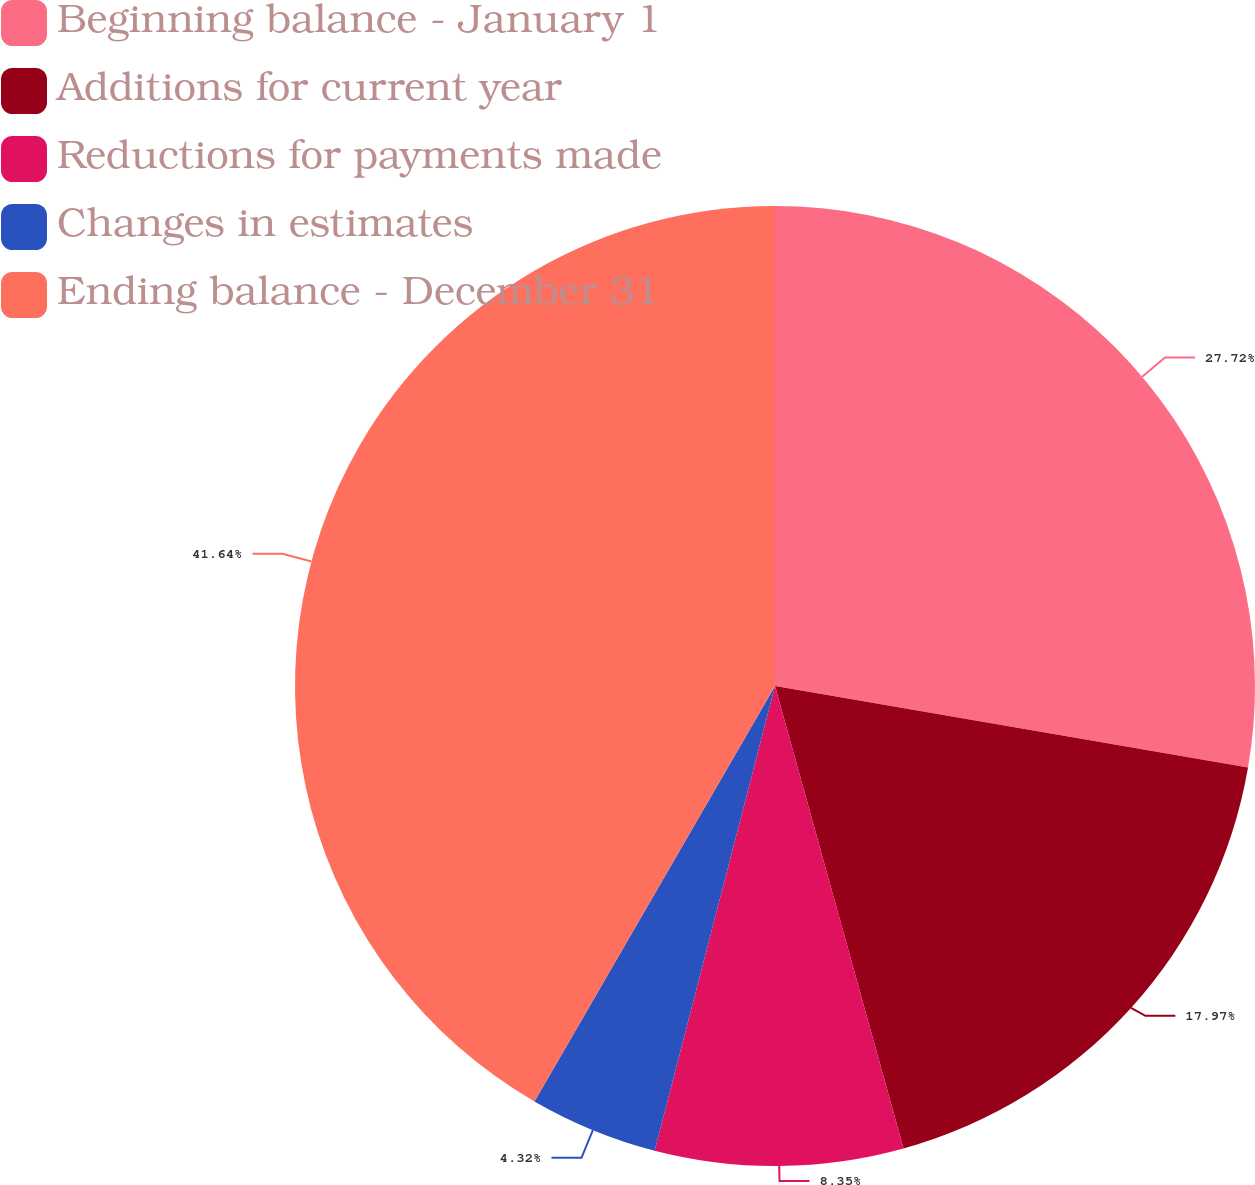Convert chart. <chart><loc_0><loc_0><loc_500><loc_500><pie_chart><fcel>Beginning balance - January 1<fcel>Additions for current year<fcel>Reductions for payments made<fcel>Changes in estimates<fcel>Ending balance - December 31<nl><fcel>27.72%<fcel>17.97%<fcel>8.35%<fcel>4.32%<fcel>41.65%<nl></chart> 